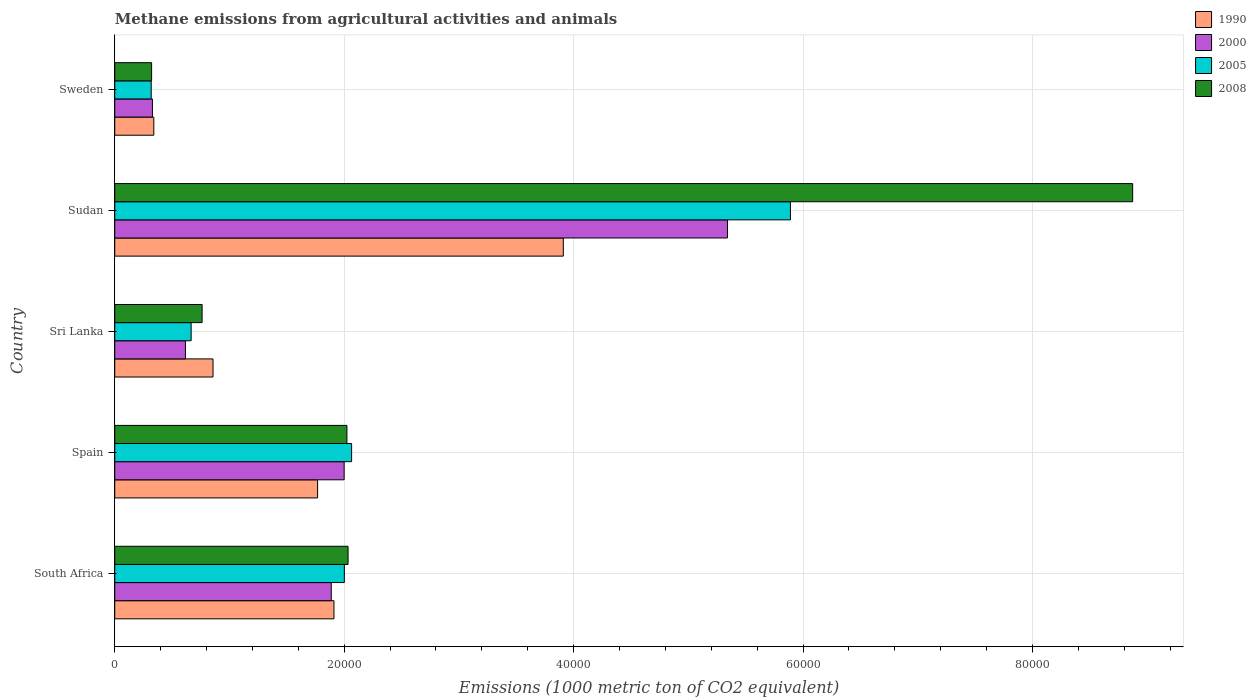How many bars are there on the 5th tick from the top?
Your response must be concise. 4. How many bars are there on the 1st tick from the bottom?
Provide a short and direct response. 4. What is the label of the 3rd group of bars from the top?
Your answer should be compact. Sri Lanka. What is the amount of methane emitted in 2008 in Sri Lanka?
Keep it short and to the point. 7614.5. Across all countries, what is the maximum amount of methane emitted in 2005?
Provide a succinct answer. 5.89e+04. Across all countries, what is the minimum amount of methane emitted in 2005?
Keep it short and to the point. 3177.6. In which country was the amount of methane emitted in 1990 maximum?
Offer a terse response. Sudan. What is the total amount of methane emitted in 2005 in the graph?
Make the answer very short. 1.09e+05. What is the difference between the amount of methane emitted in 2000 in Spain and that in Sri Lanka?
Ensure brevity in your answer.  1.38e+04. What is the difference between the amount of methane emitted in 2005 in Sudan and the amount of methane emitted in 1990 in South Africa?
Your response must be concise. 3.98e+04. What is the average amount of methane emitted in 1990 per country?
Make the answer very short. 1.76e+04. What is the difference between the amount of methane emitted in 2000 and amount of methane emitted in 1990 in Spain?
Offer a terse response. 2314.1. What is the ratio of the amount of methane emitted in 2005 in South Africa to that in Sudan?
Your answer should be very brief. 0.34. Is the difference between the amount of methane emitted in 2000 in South Africa and Sudan greater than the difference between the amount of methane emitted in 1990 in South Africa and Sudan?
Provide a short and direct response. No. What is the difference between the highest and the second highest amount of methane emitted in 2005?
Provide a short and direct response. 3.83e+04. What is the difference between the highest and the lowest amount of methane emitted in 2005?
Your answer should be very brief. 5.57e+04. In how many countries, is the amount of methane emitted in 2005 greater than the average amount of methane emitted in 2005 taken over all countries?
Give a very brief answer. 1. Is it the case that in every country, the sum of the amount of methane emitted in 2008 and amount of methane emitted in 2000 is greater than the sum of amount of methane emitted in 2005 and amount of methane emitted in 1990?
Offer a terse response. No. How many bars are there?
Provide a short and direct response. 20. What is the difference between two consecutive major ticks on the X-axis?
Your answer should be compact. 2.00e+04. Are the values on the major ticks of X-axis written in scientific E-notation?
Keep it short and to the point. No. Does the graph contain any zero values?
Provide a short and direct response. No. Where does the legend appear in the graph?
Keep it short and to the point. Top right. How are the legend labels stacked?
Your answer should be compact. Vertical. What is the title of the graph?
Provide a short and direct response. Methane emissions from agricultural activities and animals. Does "1970" appear as one of the legend labels in the graph?
Your answer should be very brief. No. What is the label or title of the X-axis?
Ensure brevity in your answer.  Emissions (1000 metric ton of CO2 equivalent). What is the label or title of the Y-axis?
Provide a short and direct response. Country. What is the Emissions (1000 metric ton of CO2 equivalent) in 1990 in South Africa?
Give a very brief answer. 1.91e+04. What is the Emissions (1000 metric ton of CO2 equivalent) of 2000 in South Africa?
Ensure brevity in your answer.  1.89e+04. What is the Emissions (1000 metric ton of CO2 equivalent) in 2005 in South Africa?
Make the answer very short. 2.00e+04. What is the Emissions (1000 metric ton of CO2 equivalent) in 2008 in South Africa?
Make the answer very short. 2.03e+04. What is the Emissions (1000 metric ton of CO2 equivalent) in 1990 in Spain?
Your answer should be compact. 1.77e+04. What is the Emissions (1000 metric ton of CO2 equivalent) in 2000 in Spain?
Keep it short and to the point. 2.00e+04. What is the Emissions (1000 metric ton of CO2 equivalent) in 2005 in Spain?
Offer a terse response. 2.06e+04. What is the Emissions (1000 metric ton of CO2 equivalent) in 2008 in Spain?
Your answer should be very brief. 2.02e+04. What is the Emissions (1000 metric ton of CO2 equivalent) of 1990 in Sri Lanka?
Your answer should be very brief. 8565.4. What is the Emissions (1000 metric ton of CO2 equivalent) in 2000 in Sri Lanka?
Keep it short and to the point. 6161. What is the Emissions (1000 metric ton of CO2 equivalent) of 2005 in Sri Lanka?
Your response must be concise. 6658.4. What is the Emissions (1000 metric ton of CO2 equivalent) of 2008 in Sri Lanka?
Offer a very short reply. 7614.5. What is the Emissions (1000 metric ton of CO2 equivalent) in 1990 in Sudan?
Offer a very short reply. 3.91e+04. What is the Emissions (1000 metric ton of CO2 equivalent) in 2000 in Sudan?
Offer a terse response. 5.34e+04. What is the Emissions (1000 metric ton of CO2 equivalent) in 2005 in Sudan?
Your answer should be compact. 5.89e+04. What is the Emissions (1000 metric ton of CO2 equivalent) in 2008 in Sudan?
Offer a terse response. 8.87e+04. What is the Emissions (1000 metric ton of CO2 equivalent) in 1990 in Sweden?
Your answer should be very brief. 3404.5. What is the Emissions (1000 metric ton of CO2 equivalent) of 2000 in Sweden?
Make the answer very short. 3284.7. What is the Emissions (1000 metric ton of CO2 equivalent) of 2005 in Sweden?
Offer a very short reply. 3177.6. What is the Emissions (1000 metric ton of CO2 equivalent) in 2008 in Sweden?
Keep it short and to the point. 3213.3. Across all countries, what is the maximum Emissions (1000 metric ton of CO2 equivalent) of 1990?
Ensure brevity in your answer.  3.91e+04. Across all countries, what is the maximum Emissions (1000 metric ton of CO2 equivalent) in 2000?
Your answer should be very brief. 5.34e+04. Across all countries, what is the maximum Emissions (1000 metric ton of CO2 equivalent) in 2005?
Make the answer very short. 5.89e+04. Across all countries, what is the maximum Emissions (1000 metric ton of CO2 equivalent) of 2008?
Offer a terse response. 8.87e+04. Across all countries, what is the minimum Emissions (1000 metric ton of CO2 equivalent) of 1990?
Provide a succinct answer. 3404.5. Across all countries, what is the minimum Emissions (1000 metric ton of CO2 equivalent) in 2000?
Provide a succinct answer. 3284.7. Across all countries, what is the minimum Emissions (1000 metric ton of CO2 equivalent) in 2005?
Offer a terse response. 3177.6. Across all countries, what is the minimum Emissions (1000 metric ton of CO2 equivalent) of 2008?
Offer a terse response. 3213.3. What is the total Emissions (1000 metric ton of CO2 equivalent) in 1990 in the graph?
Give a very brief answer. 8.79e+04. What is the total Emissions (1000 metric ton of CO2 equivalent) in 2000 in the graph?
Provide a short and direct response. 1.02e+05. What is the total Emissions (1000 metric ton of CO2 equivalent) of 2005 in the graph?
Your answer should be very brief. 1.09e+05. What is the total Emissions (1000 metric ton of CO2 equivalent) of 2008 in the graph?
Your answer should be compact. 1.40e+05. What is the difference between the Emissions (1000 metric ton of CO2 equivalent) of 1990 in South Africa and that in Spain?
Your response must be concise. 1425.6. What is the difference between the Emissions (1000 metric ton of CO2 equivalent) in 2000 in South Africa and that in Spain?
Make the answer very short. -1123.1. What is the difference between the Emissions (1000 metric ton of CO2 equivalent) in 2005 in South Africa and that in Spain?
Your answer should be very brief. -632.9. What is the difference between the Emissions (1000 metric ton of CO2 equivalent) in 2008 in South Africa and that in Spain?
Give a very brief answer. 99.4. What is the difference between the Emissions (1000 metric ton of CO2 equivalent) in 1990 in South Africa and that in Sri Lanka?
Provide a succinct answer. 1.05e+04. What is the difference between the Emissions (1000 metric ton of CO2 equivalent) of 2000 in South Africa and that in Sri Lanka?
Provide a short and direct response. 1.27e+04. What is the difference between the Emissions (1000 metric ton of CO2 equivalent) in 2005 in South Africa and that in Sri Lanka?
Offer a very short reply. 1.34e+04. What is the difference between the Emissions (1000 metric ton of CO2 equivalent) of 2008 in South Africa and that in Sri Lanka?
Make the answer very short. 1.27e+04. What is the difference between the Emissions (1000 metric ton of CO2 equivalent) of 1990 in South Africa and that in Sudan?
Ensure brevity in your answer.  -2.00e+04. What is the difference between the Emissions (1000 metric ton of CO2 equivalent) in 2000 in South Africa and that in Sudan?
Your answer should be compact. -3.45e+04. What is the difference between the Emissions (1000 metric ton of CO2 equivalent) in 2005 in South Africa and that in Sudan?
Ensure brevity in your answer.  -3.89e+04. What is the difference between the Emissions (1000 metric ton of CO2 equivalent) in 2008 in South Africa and that in Sudan?
Provide a succinct answer. -6.84e+04. What is the difference between the Emissions (1000 metric ton of CO2 equivalent) in 1990 in South Africa and that in Sweden?
Make the answer very short. 1.57e+04. What is the difference between the Emissions (1000 metric ton of CO2 equivalent) of 2000 in South Africa and that in Sweden?
Offer a terse response. 1.56e+04. What is the difference between the Emissions (1000 metric ton of CO2 equivalent) in 2005 in South Africa and that in Sweden?
Give a very brief answer. 1.68e+04. What is the difference between the Emissions (1000 metric ton of CO2 equivalent) in 2008 in South Africa and that in Sweden?
Your response must be concise. 1.71e+04. What is the difference between the Emissions (1000 metric ton of CO2 equivalent) of 1990 in Spain and that in Sri Lanka?
Make the answer very short. 9117.2. What is the difference between the Emissions (1000 metric ton of CO2 equivalent) in 2000 in Spain and that in Sri Lanka?
Provide a short and direct response. 1.38e+04. What is the difference between the Emissions (1000 metric ton of CO2 equivalent) of 2005 in Spain and that in Sri Lanka?
Give a very brief answer. 1.40e+04. What is the difference between the Emissions (1000 metric ton of CO2 equivalent) in 2008 in Spain and that in Sri Lanka?
Ensure brevity in your answer.  1.26e+04. What is the difference between the Emissions (1000 metric ton of CO2 equivalent) of 1990 in Spain and that in Sudan?
Make the answer very short. -2.14e+04. What is the difference between the Emissions (1000 metric ton of CO2 equivalent) in 2000 in Spain and that in Sudan?
Make the answer very short. -3.34e+04. What is the difference between the Emissions (1000 metric ton of CO2 equivalent) in 2005 in Spain and that in Sudan?
Keep it short and to the point. -3.83e+04. What is the difference between the Emissions (1000 metric ton of CO2 equivalent) in 2008 in Spain and that in Sudan?
Your answer should be compact. -6.85e+04. What is the difference between the Emissions (1000 metric ton of CO2 equivalent) of 1990 in Spain and that in Sweden?
Your answer should be compact. 1.43e+04. What is the difference between the Emissions (1000 metric ton of CO2 equivalent) in 2000 in Spain and that in Sweden?
Offer a very short reply. 1.67e+04. What is the difference between the Emissions (1000 metric ton of CO2 equivalent) of 2005 in Spain and that in Sweden?
Your answer should be compact. 1.75e+04. What is the difference between the Emissions (1000 metric ton of CO2 equivalent) in 2008 in Spain and that in Sweden?
Your answer should be very brief. 1.70e+04. What is the difference between the Emissions (1000 metric ton of CO2 equivalent) of 1990 in Sri Lanka and that in Sudan?
Your answer should be very brief. -3.05e+04. What is the difference between the Emissions (1000 metric ton of CO2 equivalent) in 2000 in Sri Lanka and that in Sudan?
Provide a short and direct response. -4.73e+04. What is the difference between the Emissions (1000 metric ton of CO2 equivalent) of 2005 in Sri Lanka and that in Sudan?
Offer a very short reply. -5.22e+04. What is the difference between the Emissions (1000 metric ton of CO2 equivalent) of 2008 in Sri Lanka and that in Sudan?
Keep it short and to the point. -8.11e+04. What is the difference between the Emissions (1000 metric ton of CO2 equivalent) in 1990 in Sri Lanka and that in Sweden?
Offer a terse response. 5160.9. What is the difference between the Emissions (1000 metric ton of CO2 equivalent) in 2000 in Sri Lanka and that in Sweden?
Ensure brevity in your answer.  2876.3. What is the difference between the Emissions (1000 metric ton of CO2 equivalent) in 2005 in Sri Lanka and that in Sweden?
Make the answer very short. 3480.8. What is the difference between the Emissions (1000 metric ton of CO2 equivalent) of 2008 in Sri Lanka and that in Sweden?
Provide a succinct answer. 4401.2. What is the difference between the Emissions (1000 metric ton of CO2 equivalent) of 1990 in Sudan and that in Sweden?
Your answer should be very brief. 3.57e+04. What is the difference between the Emissions (1000 metric ton of CO2 equivalent) of 2000 in Sudan and that in Sweden?
Give a very brief answer. 5.01e+04. What is the difference between the Emissions (1000 metric ton of CO2 equivalent) of 2005 in Sudan and that in Sweden?
Offer a very short reply. 5.57e+04. What is the difference between the Emissions (1000 metric ton of CO2 equivalent) in 2008 in Sudan and that in Sweden?
Your response must be concise. 8.55e+04. What is the difference between the Emissions (1000 metric ton of CO2 equivalent) of 1990 in South Africa and the Emissions (1000 metric ton of CO2 equivalent) of 2000 in Spain?
Make the answer very short. -888.5. What is the difference between the Emissions (1000 metric ton of CO2 equivalent) in 1990 in South Africa and the Emissions (1000 metric ton of CO2 equivalent) in 2005 in Spain?
Give a very brief answer. -1539.2. What is the difference between the Emissions (1000 metric ton of CO2 equivalent) of 1990 in South Africa and the Emissions (1000 metric ton of CO2 equivalent) of 2008 in Spain?
Provide a short and direct response. -1130.3. What is the difference between the Emissions (1000 metric ton of CO2 equivalent) of 2000 in South Africa and the Emissions (1000 metric ton of CO2 equivalent) of 2005 in Spain?
Your response must be concise. -1773.8. What is the difference between the Emissions (1000 metric ton of CO2 equivalent) in 2000 in South Africa and the Emissions (1000 metric ton of CO2 equivalent) in 2008 in Spain?
Your response must be concise. -1364.9. What is the difference between the Emissions (1000 metric ton of CO2 equivalent) in 2005 in South Africa and the Emissions (1000 metric ton of CO2 equivalent) in 2008 in Spain?
Your response must be concise. -224. What is the difference between the Emissions (1000 metric ton of CO2 equivalent) of 1990 in South Africa and the Emissions (1000 metric ton of CO2 equivalent) of 2000 in Sri Lanka?
Keep it short and to the point. 1.29e+04. What is the difference between the Emissions (1000 metric ton of CO2 equivalent) in 1990 in South Africa and the Emissions (1000 metric ton of CO2 equivalent) in 2005 in Sri Lanka?
Give a very brief answer. 1.24e+04. What is the difference between the Emissions (1000 metric ton of CO2 equivalent) in 1990 in South Africa and the Emissions (1000 metric ton of CO2 equivalent) in 2008 in Sri Lanka?
Your answer should be compact. 1.15e+04. What is the difference between the Emissions (1000 metric ton of CO2 equivalent) in 2000 in South Africa and the Emissions (1000 metric ton of CO2 equivalent) in 2005 in Sri Lanka?
Your answer should be very brief. 1.22e+04. What is the difference between the Emissions (1000 metric ton of CO2 equivalent) in 2000 in South Africa and the Emissions (1000 metric ton of CO2 equivalent) in 2008 in Sri Lanka?
Your answer should be very brief. 1.13e+04. What is the difference between the Emissions (1000 metric ton of CO2 equivalent) in 2005 in South Africa and the Emissions (1000 metric ton of CO2 equivalent) in 2008 in Sri Lanka?
Your answer should be very brief. 1.24e+04. What is the difference between the Emissions (1000 metric ton of CO2 equivalent) in 1990 in South Africa and the Emissions (1000 metric ton of CO2 equivalent) in 2000 in Sudan?
Provide a succinct answer. -3.43e+04. What is the difference between the Emissions (1000 metric ton of CO2 equivalent) of 1990 in South Africa and the Emissions (1000 metric ton of CO2 equivalent) of 2005 in Sudan?
Your answer should be very brief. -3.98e+04. What is the difference between the Emissions (1000 metric ton of CO2 equivalent) in 1990 in South Africa and the Emissions (1000 metric ton of CO2 equivalent) in 2008 in Sudan?
Keep it short and to the point. -6.96e+04. What is the difference between the Emissions (1000 metric ton of CO2 equivalent) in 2000 in South Africa and the Emissions (1000 metric ton of CO2 equivalent) in 2005 in Sudan?
Give a very brief answer. -4.00e+04. What is the difference between the Emissions (1000 metric ton of CO2 equivalent) of 2000 in South Africa and the Emissions (1000 metric ton of CO2 equivalent) of 2008 in Sudan?
Give a very brief answer. -6.99e+04. What is the difference between the Emissions (1000 metric ton of CO2 equivalent) of 2005 in South Africa and the Emissions (1000 metric ton of CO2 equivalent) of 2008 in Sudan?
Give a very brief answer. -6.87e+04. What is the difference between the Emissions (1000 metric ton of CO2 equivalent) in 1990 in South Africa and the Emissions (1000 metric ton of CO2 equivalent) in 2000 in Sweden?
Provide a succinct answer. 1.58e+04. What is the difference between the Emissions (1000 metric ton of CO2 equivalent) in 1990 in South Africa and the Emissions (1000 metric ton of CO2 equivalent) in 2005 in Sweden?
Keep it short and to the point. 1.59e+04. What is the difference between the Emissions (1000 metric ton of CO2 equivalent) of 1990 in South Africa and the Emissions (1000 metric ton of CO2 equivalent) of 2008 in Sweden?
Ensure brevity in your answer.  1.59e+04. What is the difference between the Emissions (1000 metric ton of CO2 equivalent) of 2000 in South Africa and the Emissions (1000 metric ton of CO2 equivalent) of 2005 in Sweden?
Offer a very short reply. 1.57e+04. What is the difference between the Emissions (1000 metric ton of CO2 equivalent) of 2000 in South Africa and the Emissions (1000 metric ton of CO2 equivalent) of 2008 in Sweden?
Keep it short and to the point. 1.57e+04. What is the difference between the Emissions (1000 metric ton of CO2 equivalent) of 2005 in South Africa and the Emissions (1000 metric ton of CO2 equivalent) of 2008 in Sweden?
Your response must be concise. 1.68e+04. What is the difference between the Emissions (1000 metric ton of CO2 equivalent) in 1990 in Spain and the Emissions (1000 metric ton of CO2 equivalent) in 2000 in Sri Lanka?
Give a very brief answer. 1.15e+04. What is the difference between the Emissions (1000 metric ton of CO2 equivalent) of 1990 in Spain and the Emissions (1000 metric ton of CO2 equivalent) of 2005 in Sri Lanka?
Ensure brevity in your answer.  1.10e+04. What is the difference between the Emissions (1000 metric ton of CO2 equivalent) in 1990 in Spain and the Emissions (1000 metric ton of CO2 equivalent) in 2008 in Sri Lanka?
Offer a very short reply. 1.01e+04. What is the difference between the Emissions (1000 metric ton of CO2 equivalent) in 2000 in Spain and the Emissions (1000 metric ton of CO2 equivalent) in 2005 in Sri Lanka?
Keep it short and to the point. 1.33e+04. What is the difference between the Emissions (1000 metric ton of CO2 equivalent) in 2000 in Spain and the Emissions (1000 metric ton of CO2 equivalent) in 2008 in Sri Lanka?
Provide a short and direct response. 1.24e+04. What is the difference between the Emissions (1000 metric ton of CO2 equivalent) in 2005 in Spain and the Emissions (1000 metric ton of CO2 equivalent) in 2008 in Sri Lanka?
Provide a succinct answer. 1.30e+04. What is the difference between the Emissions (1000 metric ton of CO2 equivalent) of 1990 in Spain and the Emissions (1000 metric ton of CO2 equivalent) of 2000 in Sudan?
Ensure brevity in your answer.  -3.57e+04. What is the difference between the Emissions (1000 metric ton of CO2 equivalent) in 1990 in Spain and the Emissions (1000 metric ton of CO2 equivalent) in 2005 in Sudan?
Make the answer very short. -4.12e+04. What is the difference between the Emissions (1000 metric ton of CO2 equivalent) of 1990 in Spain and the Emissions (1000 metric ton of CO2 equivalent) of 2008 in Sudan?
Provide a succinct answer. -7.11e+04. What is the difference between the Emissions (1000 metric ton of CO2 equivalent) of 2000 in Spain and the Emissions (1000 metric ton of CO2 equivalent) of 2005 in Sudan?
Your answer should be compact. -3.89e+04. What is the difference between the Emissions (1000 metric ton of CO2 equivalent) of 2000 in Spain and the Emissions (1000 metric ton of CO2 equivalent) of 2008 in Sudan?
Provide a succinct answer. -6.87e+04. What is the difference between the Emissions (1000 metric ton of CO2 equivalent) in 2005 in Spain and the Emissions (1000 metric ton of CO2 equivalent) in 2008 in Sudan?
Your response must be concise. -6.81e+04. What is the difference between the Emissions (1000 metric ton of CO2 equivalent) of 1990 in Spain and the Emissions (1000 metric ton of CO2 equivalent) of 2000 in Sweden?
Keep it short and to the point. 1.44e+04. What is the difference between the Emissions (1000 metric ton of CO2 equivalent) in 1990 in Spain and the Emissions (1000 metric ton of CO2 equivalent) in 2005 in Sweden?
Offer a terse response. 1.45e+04. What is the difference between the Emissions (1000 metric ton of CO2 equivalent) in 1990 in Spain and the Emissions (1000 metric ton of CO2 equivalent) in 2008 in Sweden?
Your response must be concise. 1.45e+04. What is the difference between the Emissions (1000 metric ton of CO2 equivalent) of 2000 in Spain and the Emissions (1000 metric ton of CO2 equivalent) of 2005 in Sweden?
Your answer should be compact. 1.68e+04. What is the difference between the Emissions (1000 metric ton of CO2 equivalent) in 2000 in Spain and the Emissions (1000 metric ton of CO2 equivalent) in 2008 in Sweden?
Your response must be concise. 1.68e+04. What is the difference between the Emissions (1000 metric ton of CO2 equivalent) in 2005 in Spain and the Emissions (1000 metric ton of CO2 equivalent) in 2008 in Sweden?
Make the answer very short. 1.74e+04. What is the difference between the Emissions (1000 metric ton of CO2 equivalent) of 1990 in Sri Lanka and the Emissions (1000 metric ton of CO2 equivalent) of 2000 in Sudan?
Offer a terse response. -4.48e+04. What is the difference between the Emissions (1000 metric ton of CO2 equivalent) of 1990 in Sri Lanka and the Emissions (1000 metric ton of CO2 equivalent) of 2005 in Sudan?
Offer a terse response. -5.03e+04. What is the difference between the Emissions (1000 metric ton of CO2 equivalent) in 1990 in Sri Lanka and the Emissions (1000 metric ton of CO2 equivalent) in 2008 in Sudan?
Offer a very short reply. -8.02e+04. What is the difference between the Emissions (1000 metric ton of CO2 equivalent) of 2000 in Sri Lanka and the Emissions (1000 metric ton of CO2 equivalent) of 2005 in Sudan?
Give a very brief answer. -5.27e+04. What is the difference between the Emissions (1000 metric ton of CO2 equivalent) of 2000 in Sri Lanka and the Emissions (1000 metric ton of CO2 equivalent) of 2008 in Sudan?
Your response must be concise. -8.26e+04. What is the difference between the Emissions (1000 metric ton of CO2 equivalent) of 2005 in Sri Lanka and the Emissions (1000 metric ton of CO2 equivalent) of 2008 in Sudan?
Ensure brevity in your answer.  -8.21e+04. What is the difference between the Emissions (1000 metric ton of CO2 equivalent) in 1990 in Sri Lanka and the Emissions (1000 metric ton of CO2 equivalent) in 2000 in Sweden?
Your answer should be very brief. 5280.7. What is the difference between the Emissions (1000 metric ton of CO2 equivalent) of 1990 in Sri Lanka and the Emissions (1000 metric ton of CO2 equivalent) of 2005 in Sweden?
Offer a very short reply. 5387.8. What is the difference between the Emissions (1000 metric ton of CO2 equivalent) in 1990 in Sri Lanka and the Emissions (1000 metric ton of CO2 equivalent) in 2008 in Sweden?
Your answer should be very brief. 5352.1. What is the difference between the Emissions (1000 metric ton of CO2 equivalent) in 2000 in Sri Lanka and the Emissions (1000 metric ton of CO2 equivalent) in 2005 in Sweden?
Keep it short and to the point. 2983.4. What is the difference between the Emissions (1000 metric ton of CO2 equivalent) in 2000 in Sri Lanka and the Emissions (1000 metric ton of CO2 equivalent) in 2008 in Sweden?
Provide a short and direct response. 2947.7. What is the difference between the Emissions (1000 metric ton of CO2 equivalent) of 2005 in Sri Lanka and the Emissions (1000 metric ton of CO2 equivalent) of 2008 in Sweden?
Your response must be concise. 3445.1. What is the difference between the Emissions (1000 metric ton of CO2 equivalent) in 1990 in Sudan and the Emissions (1000 metric ton of CO2 equivalent) in 2000 in Sweden?
Offer a terse response. 3.58e+04. What is the difference between the Emissions (1000 metric ton of CO2 equivalent) of 1990 in Sudan and the Emissions (1000 metric ton of CO2 equivalent) of 2005 in Sweden?
Ensure brevity in your answer.  3.59e+04. What is the difference between the Emissions (1000 metric ton of CO2 equivalent) of 1990 in Sudan and the Emissions (1000 metric ton of CO2 equivalent) of 2008 in Sweden?
Provide a succinct answer. 3.59e+04. What is the difference between the Emissions (1000 metric ton of CO2 equivalent) in 2000 in Sudan and the Emissions (1000 metric ton of CO2 equivalent) in 2005 in Sweden?
Give a very brief answer. 5.02e+04. What is the difference between the Emissions (1000 metric ton of CO2 equivalent) in 2000 in Sudan and the Emissions (1000 metric ton of CO2 equivalent) in 2008 in Sweden?
Offer a very short reply. 5.02e+04. What is the difference between the Emissions (1000 metric ton of CO2 equivalent) in 2005 in Sudan and the Emissions (1000 metric ton of CO2 equivalent) in 2008 in Sweden?
Your answer should be very brief. 5.57e+04. What is the average Emissions (1000 metric ton of CO2 equivalent) of 1990 per country?
Your answer should be very brief. 1.76e+04. What is the average Emissions (1000 metric ton of CO2 equivalent) of 2000 per country?
Your answer should be compact. 2.03e+04. What is the average Emissions (1000 metric ton of CO2 equivalent) of 2005 per country?
Your answer should be very brief. 2.19e+04. What is the average Emissions (1000 metric ton of CO2 equivalent) in 2008 per country?
Your response must be concise. 2.80e+04. What is the difference between the Emissions (1000 metric ton of CO2 equivalent) of 1990 and Emissions (1000 metric ton of CO2 equivalent) of 2000 in South Africa?
Offer a very short reply. 234.6. What is the difference between the Emissions (1000 metric ton of CO2 equivalent) of 1990 and Emissions (1000 metric ton of CO2 equivalent) of 2005 in South Africa?
Your answer should be compact. -906.3. What is the difference between the Emissions (1000 metric ton of CO2 equivalent) of 1990 and Emissions (1000 metric ton of CO2 equivalent) of 2008 in South Africa?
Keep it short and to the point. -1229.7. What is the difference between the Emissions (1000 metric ton of CO2 equivalent) of 2000 and Emissions (1000 metric ton of CO2 equivalent) of 2005 in South Africa?
Make the answer very short. -1140.9. What is the difference between the Emissions (1000 metric ton of CO2 equivalent) in 2000 and Emissions (1000 metric ton of CO2 equivalent) in 2008 in South Africa?
Offer a very short reply. -1464.3. What is the difference between the Emissions (1000 metric ton of CO2 equivalent) in 2005 and Emissions (1000 metric ton of CO2 equivalent) in 2008 in South Africa?
Your response must be concise. -323.4. What is the difference between the Emissions (1000 metric ton of CO2 equivalent) of 1990 and Emissions (1000 metric ton of CO2 equivalent) of 2000 in Spain?
Offer a very short reply. -2314.1. What is the difference between the Emissions (1000 metric ton of CO2 equivalent) in 1990 and Emissions (1000 metric ton of CO2 equivalent) in 2005 in Spain?
Provide a short and direct response. -2964.8. What is the difference between the Emissions (1000 metric ton of CO2 equivalent) of 1990 and Emissions (1000 metric ton of CO2 equivalent) of 2008 in Spain?
Give a very brief answer. -2555.9. What is the difference between the Emissions (1000 metric ton of CO2 equivalent) of 2000 and Emissions (1000 metric ton of CO2 equivalent) of 2005 in Spain?
Ensure brevity in your answer.  -650.7. What is the difference between the Emissions (1000 metric ton of CO2 equivalent) of 2000 and Emissions (1000 metric ton of CO2 equivalent) of 2008 in Spain?
Make the answer very short. -241.8. What is the difference between the Emissions (1000 metric ton of CO2 equivalent) of 2005 and Emissions (1000 metric ton of CO2 equivalent) of 2008 in Spain?
Offer a terse response. 408.9. What is the difference between the Emissions (1000 metric ton of CO2 equivalent) of 1990 and Emissions (1000 metric ton of CO2 equivalent) of 2000 in Sri Lanka?
Your answer should be compact. 2404.4. What is the difference between the Emissions (1000 metric ton of CO2 equivalent) in 1990 and Emissions (1000 metric ton of CO2 equivalent) in 2005 in Sri Lanka?
Offer a terse response. 1907. What is the difference between the Emissions (1000 metric ton of CO2 equivalent) of 1990 and Emissions (1000 metric ton of CO2 equivalent) of 2008 in Sri Lanka?
Your answer should be compact. 950.9. What is the difference between the Emissions (1000 metric ton of CO2 equivalent) of 2000 and Emissions (1000 metric ton of CO2 equivalent) of 2005 in Sri Lanka?
Your answer should be compact. -497.4. What is the difference between the Emissions (1000 metric ton of CO2 equivalent) of 2000 and Emissions (1000 metric ton of CO2 equivalent) of 2008 in Sri Lanka?
Offer a very short reply. -1453.5. What is the difference between the Emissions (1000 metric ton of CO2 equivalent) of 2005 and Emissions (1000 metric ton of CO2 equivalent) of 2008 in Sri Lanka?
Your answer should be compact. -956.1. What is the difference between the Emissions (1000 metric ton of CO2 equivalent) of 1990 and Emissions (1000 metric ton of CO2 equivalent) of 2000 in Sudan?
Offer a terse response. -1.43e+04. What is the difference between the Emissions (1000 metric ton of CO2 equivalent) in 1990 and Emissions (1000 metric ton of CO2 equivalent) in 2005 in Sudan?
Your answer should be very brief. -1.98e+04. What is the difference between the Emissions (1000 metric ton of CO2 equivalent) of 1990 and Emissions (1000 metric ton of CO2 equivalent) of 2008 in Sudan?
Make the answer very short. -4.96e+04. What is the difference between the Emissions (1000 metric ton of CO2 equivalent) of 2000 and Emissions (1000 metric ton of CO2 equivalent) of 2005 in Sudan?
Keep it short and to the point. -5487.9. What is the difference between the Emissions (1000 metric ton of CO2 equivalent) in 2000 and Emissions (1000 metric ton of CO2 equivalent) in 2008 in Sudan?
Keep it short and to the point. -3.53e+04. What is the difference between the Emissions (1000 metric ton of CO2 equivalent) of 2005 and Emissions (1000 metric ton of CO2 equivalent) of 2008 in Sudan?
Your answer should be compact. -2.98e+04. What is the difference between the Emissions (1000 metric ton of CO2 equivalent) in 1990 and Emissions (1000 metric ton of CO2 equivalent) in 2000 in Sweden?
Your answer should be very brief. 119.8. What is the difference between the Emissions (1000 metric ton of CO2 equivalent) in 1990 and Emissions (1000 metric ton of CO2 equivalent) in 2005 in Sweden?
Give a very brief answer. 226.9. What is the difference between the Emissions (1000 metric ton of CO2 equivalent) of 1990 and Emissions (1000 metric ton of CO2 equivalent) of 2008 in Sweden?
Make the answer very short. 191.2. What is the difference between the Emissions (1000 metric ton of CO2 equivalent) of 2000 and Emissions (1000 metric ton of CO2 equivalent) of 2005 in Sweden?
Your response must be concise. 107.1. What is the difference between the Emissions (1000 metric ton of CO2 equivalent) in 2000 and Emissions (1000 metric ton of CO2 equivalent) in 2008 in Sweden?
Offer a terse response. 71.4. What is the difference between the Emissions (1000 metric ton of CO2 equivalent) in 2005 and Emissions (1000 metric ton of CO2 equivalent) in 2008 in Sweden?
Ensure brevity in your answer.  -35.7. What is the ratio of the Emissions (1000 metric ton of CO2 equivalent) in 1990 in South Africa to that in Spain?
Provide a short and direct response. 1.08. What is the ratio of the Emissions (1000 metric ton of CO2 equivalent) in 2000 in South Africa to that in Spain?
Keep it short and to the point. 0.94. What is the ratio of the Emissions (1000 metric ton of CO2 equivalent) in 2005 in South Africa to that in Spain?
Ensure brevity in your answer.  0.97. What is the ratio of the Emissions (1000 metric ton of CO2 equivalent) in 2008 in South Africa to that in Spain?
Provide a succinct answer. 1. What is the ratio of the Emissions (1000 metric ton of CO2 equivalent) in 1990 in South Africa to that in Sri Lanka?
Your answer should be very brief. 2.23. What is the ratio of the Emissions (1000 metric ton of CO2 equivalent) in 2000 in South Africa to that in Sri Lanka?
Make the answer very short. 3.06. What is the ratio of the Emissions (1000 metric ton of CO2 equivalent) of 2005 in South Africa to that in Sri Lanka?
Give a very brief answer. 3.01. What is the ratio of the Emissions (1000 metric ton of CO2 equivalent) of 2008 in South Africa to that in Sri Lanka?
Provide a succinct answer. 2.67. What is the ratio of the Emissions (1000 metric ton of CO2 equivalent) in 1990 in South Africa to that in Sudan?
Provide a short and direct response. 0.49. What is the ratio of the Emissions (1000 metric ton of CO2 equivalent) in 2000 in South Africa to that in Sudan?
Your answer should be very brief. 0.35. What is the ratio of the Emissions (1000 metric ton of CO2 equivalent) in 2005 in South Africa to that in Sudan?
Offer a very short reply. 0.34. What is the ratio of the Emissions (1000 metric ton of CO2 equivalent) in 2008 in South Africa to that in Sudan?
Provide a succinct answer. 0.23. What is the ratio of the Emissions (1000 metric ton of CO2 equivalent) in 1990 in South Africa to that in Sweden?
Offer a very short reply. 5.61. What is the ratio of the Emissions (1000 metric ton of CO2 equivalent) of 2000 in South Africa to that in Sweden?
Offer a very short reply. 5.75. What is the ratio of the Emissions (1000 metric ton of CO2 equivalent) of 2005 in South Africa to that in Sweden?
Offer a very short reply. 6.3. What is the ratio of the Emissions (1000 metric ton of CO2 equivalent) in 2008 in South Africa to that in Sweden?
Keep it short and to the point. 6.33. What is the ratio of the Emissions (1000 metric ton of CO2 equivalent) in 1990 in Spain to that in Sri Lanka?
Provide a succinct answer. 2.06. What is the ratio of the Emissions (1000 metric ton of CO2 equivalent) of 2000 in Spain to that in Sri Lanka?
Ensure brevity in your answer.  3.25. What is the ratio of the Emissions (1000 metric ton of CO2 equivalent) of 2005 in Spain to that in Sri Lanka?
Provide a succinct answer. 3.1. What is the ratio of the Emissions (1000 metric ton of CO2 equivalent) in 2008 in Spain to that in Sri Lanka?
Provide a short and direct response. 2.66. What is the ratio of the Emissions (1000 metric ton of CO2 equivalent) of 1990 in Spain to that in Sudan?
Your answer should be compact. 0.45. What is the ratio of the Emissions (1000 metric ton of CO2 equivalent) of 2000 in Spain to that in Sudan?
Your answer should be compact. 0.37. What is the ratio of the Emissions (1000 metric ton of CO2 equivalent) in 2005 in Spain to that in Sudan?
Ensure brevity in your answer.  0.35. What is the ratio of the Emissions (1000 metric ton of CO2 equivalent) in 2008 in Spain to that in Sudan?
Your response must be concise. 0.23. What is the ratio of the Emissions (1000 metric ton of CO2 equivalent) of 1990 in Spain to that in Sweden?
Your response must be concise. 5.19. What is the ratio of the Emissions (1000 metric ton of CO2 equivalent) of 2000 in Spain to that in Sweden?
Your answer should be very brief. 6.09. What is the ratio of the Emissions (1000 metric ton of CO2 equivalent) of 2005 in Spain to that in Sweden?
Provide a succinct answer. 6.5. What is the ratio of the Emissions (1000 metric ton of CO2 equivalent) in 2008 in Spain to that in Sweden?
Provide a succinct answer. 6.3. What is the ratio of the Emissions (1000 metric ton of CO2 equivalent) of 1990 in Sri Lanka to that in Sudan?
Give a very brief answer. 0.22. What is the ratio of the Emissions (1000 metric ton of CO2 equivalent) in 2000 in Sri Lanka to that in Sudan?
Make the answer very short. 0.12. What is the ratio of the Emissions (1000 metric ton of CO2 equivalent) in 2005 in Sri Lanka to that in Sudan?
Your response must be concise. 0.11. What is the ratio of the Emissions (1000 metric ton of CO2 equivalent) in 2008 in Sri Lanka to that in Sudan?
Offer a very short reply. 0.09. What is the ratio of the Emissions (1000 metric ton of CO2 equivalent) in 1990 in Sri Lanka to that in Sweden?
Your answer should be compact. 2.52. What is the ratio of the Emissions (1000 metric ton of CO2 equivalent) of 2000 in Sri Lanka to that in Sweden?
Make the answer very short. 1.88. What is the ratio of the Emissions (1000 metric ton of CO2 equivalent) in 2005 in Sri Lanka to that in Sweden?
Your answer should be compact. 2.1. What is the ratio of the Emissions (1000 metric ton of CO2 equivalent) of 2008 in Sri Lanka to that in Sweden?
Provide a succinct answer. 2.37. What is the ratio of the Emissions (1000 metric ton of CO2 equivalent) in 1990 in Sudan to that in Sweden?
Provide a short and direct response. 11.49. What is the ratio of the Emissions (1000 metric ton of CO2 equivalent) in 2000 in Sudan to that in Sweden?
Your response must be concise. 16.26. What is the ratio of the Emissions (1000 metric ton of CO2 equivalent) of 2005 in Sudan to that in Sweden?
Give a very brief answer. 18.54. What is the ratio of the Emissions (1000 metric ton of CO2 equivalent) in 2008 in Sudan to that in Sweden?
Offer a terse response. 27.62. What is the difference between the highest and the second highest Emissions (1000 metric ton of CO2 equivalent) in 1990?
Offer a terse response. 2.00e+04. What is the difference between the highest and the second highest Emissions (1000 metric ton of CO2 equivalent) of 2000?
Keep it short and to the point. 3.34e+04. What is the difference between the highest and the second highest Emissions (1000 metric ton of CO2 equivalent) in 2005?
Provide a succinct answer. 3.83e+04. What is the difference between the highest and the second highest Emissions (1000 metric ton of CO2 equivalent) in 2008?
Your response must be concise. 6.84e+04. What is the difference between the highest and the lowest Emissions (1000 metric ton of CO2 equivalent) of 1990?
Offer a terse response. 3.57e+04. What is the difference between the highest and the lowest Emissions (1000 metric ton of CO2 equivalent) in 2000?
Your answer should be very brief. 5.01e+04. What is the difference between the highest and the lowest Emissions (1000 metric ton of CO2 equivalent) of 2005?
Give a very brief answer. 5.57e+04. What is the difference between the highest and the lowest Emissions (1000 metric ton of CO2 equivalent) of 2008?
Provide a succinct answer. 8.55e+04. 